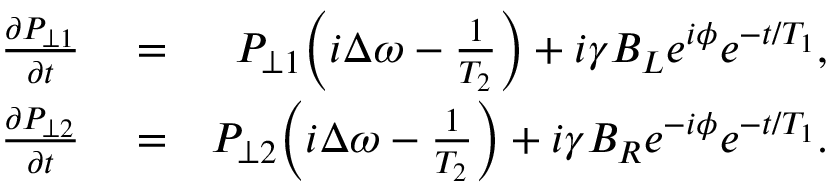<formula> <loc_0><loc_0><loc_500><loc_500>\begin{array} { r l r } { \frac { \partial P _ { \perp 1 } } { \partial t } } & = } & { P _ { \perp 1 } \left ( i \Delta \omega - \frac { 1 } { T _ { 2 } } \right ) + i \gamma B _ { L } e ^ { i \phi } e ^ { - t / T _ { 1 } } , } \\ { \frac { \partial P _ { \perp 2 } } { \partial t } } & = } & { P _ { \perp 2 } \left ( i \Delta \omega - \frac { 1 } { T _ { 2 } } \right ) + i \gamma B _ { R } e ^ { - i \phi } e ^ { - t / T _ { 1 } } . } \end{array}</formula> 